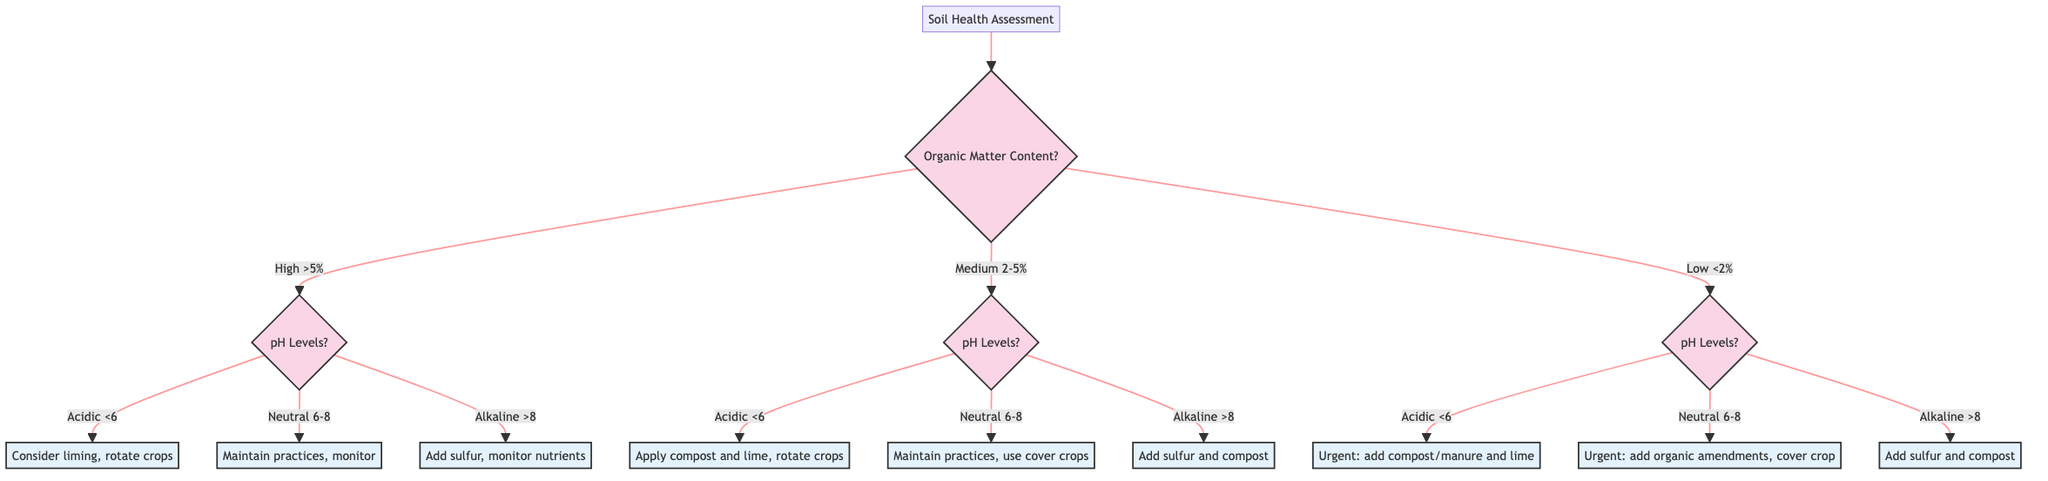What are the three categories of organic matter content in the diagram? The diagram indicates three categories: High (>5%), Medium (2-5%), and Low (<2%). These categories are found at the first decision point regarding organic matter content.
Answer: High, Medium, Low What is the action recommended for low organic matter content with neutral pH levels? The action is "Urgent need for organic amendments. Consider cover cropping and crop rotation." This can be found at the node corresponding to Low Organic Matter Content and Neutral pH.
Answer: Urgent need for organic amendments. Consider cover cropping and crop rotation How many nodes represent actions in the diagram? There are six nodes representing actions in the diagram: three for High, three for Medium, and three for Low organic matter contents. Summing them gives a total of nine action nodes.
Answer: Nine What should be considered if the soil has medium organic matter and is acidic? If the soil has medium organic matter and is acidic, the recommendation is to "Consider compost application and liming. Rotate crops to increase organic matter." This follows from the Medium Organic Matter Content decision and the Acidic pH level decision.
Answer: Consider compost application and liming. Rotate crops to increase organic matter What action is suggested for high organic matter content in alkaline soil? The recommended action is to "Add sulfur or organic amendments to lower pH. Monitor for nutrient deficiencies." This is indicated at the node for high organic matter and alkaline soil.
Answer: Add sulfur or organic amendments to lower pH. Monitor for nutrient deficiencies What are the three possible pH levels assessed after determining organic matter content? The three possible pH levels assessed are Acidic (<6), Neutral (6-8), and Alkaline (>8). Each level leads to different subsequent actions based on the organic matter content decision made previously.
Answer: Acidic, Neutral, Alkaline What is the first question asked in the decision tree? The first question asked is about the organic matter content of the soil, specifically, "What is the soil organic matter content?" It's the starting point of the decision-making flow.
Answer: What is the soil organic matter content? What is the decision resulting from high organic matter content with neutral pH levels? The decision resulting from high organic matter content with neutral pH levels is "Maintain current practices. Monitor for deficiencies or contamination." This is the outcome for the neutral option under high OM.
Answer: Maintain current practices. Monitor for deficiencies or contamination 